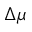Convert formula to latex. <formula><loc_0><loc_0><loc_500><loc_500>\Delta \mu</formula> 